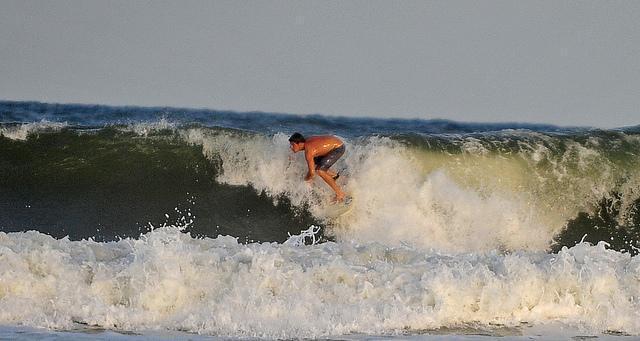How many carrots are on top of the cartoon image?
Give a very brief answer. 0. 